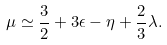<formula> <loc_0><loc_0><loc_500><loc_500>\mu \simeq \frac { 3 } { 2 } + 3 \epsilon - \eta + \frac { 2 } { 3 } \lambda .</formula> 